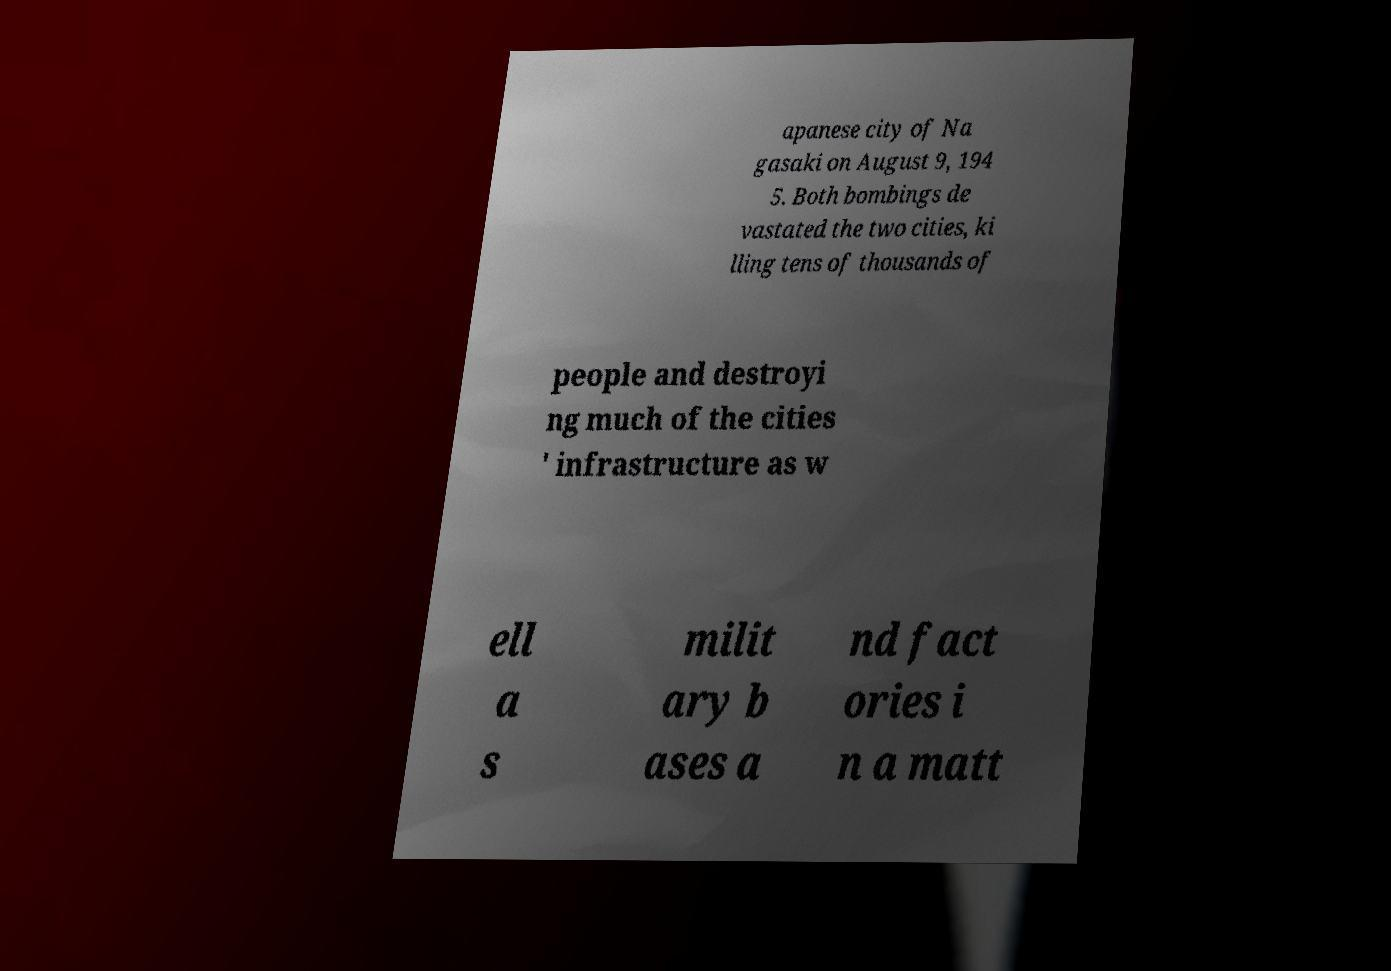I need the written content from this picture converted into text. Can you do that? apanese city of Na gasaki on August 9, 194 5. Both bombings de vastated the two cities, ki lling tens of thousands of people and destroyi ng much of the cities ' infrastructure as w ell a s milit ary b ases a nd fact ories i n a matt 